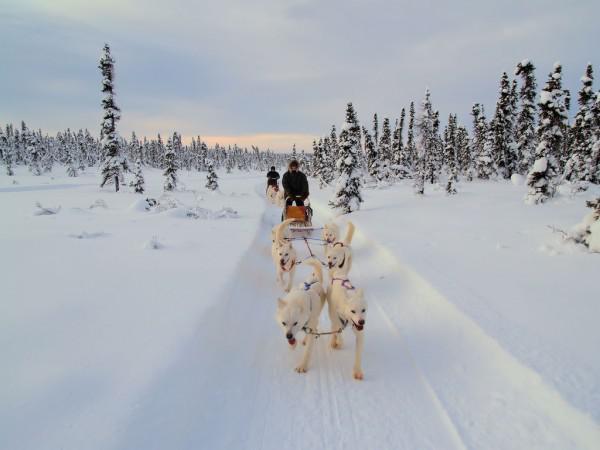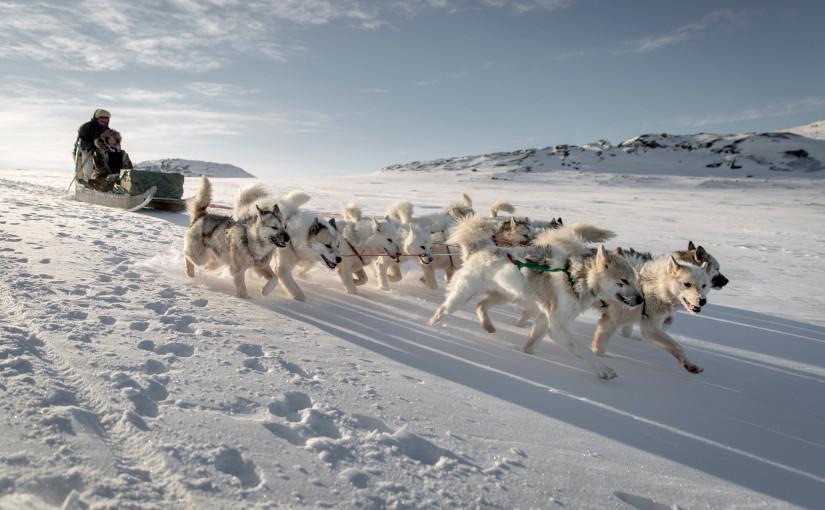The first image is the image on the left, the second image is the image on the right. Examine the images to the left and right. Is the description "One image shows at least one sled dog team moving horizontally rightward, and the other image shows at least one dog team moving forward at some angle." accurate? Answer yes or no. No. The first image is the image on the left, the second image is the image on the right. Considering the images on both sides, is "There are trees visible in both images." valid? Answer yes or no. No. 